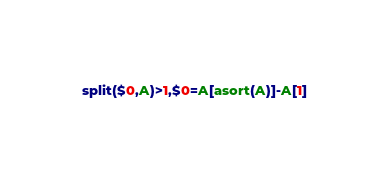Convert code to text. <code><loc_0><loc_0><loc_500><loc_500><_Awk_>split($0,A)>1,$0=A[asort(A)]-A[1]</code> 